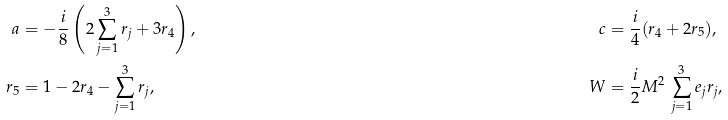<formula> <loc_0><loc_0><loc_500><loc_500>a & = - \frac { i } { 8 } \left ( 2 \sum _ { j = 1 } ^ { 3 } r _ { j } + 3 r _ { 4 } \right ) , & c & = \frac { i } { 4 } ( r _ { 4 } + 2 r _ { 5 } ) , \\ r _ { 5 } & = 1 - 2 r _ { 4 } - \sum _ { j = 1 } ^ { 3 } r _ { j } , & W & = \frac { i } { 2 } M ^ { 2 } \, \sum _ { j = 1 } ^ { 3 } e _ { j } r _ { j } ,</formula> 